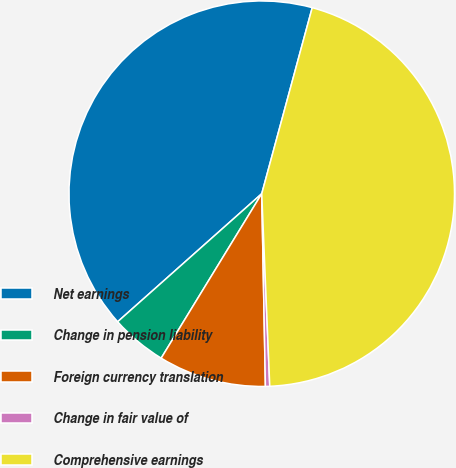Convert chart. <chart><loc_0><loc_0><loc_500><loc_500><pie_chart><fcel>Net earnings<fcel>Change in pension liability<fcel>Foreign currency translation<fcel>Change in fair value of<fcel>Comprehensive earnings<nl><fcel>40.78%<fcel>4.7%<fcel>9.04%<fcel>0.36%<fcel>45.12%<nl></chart> 